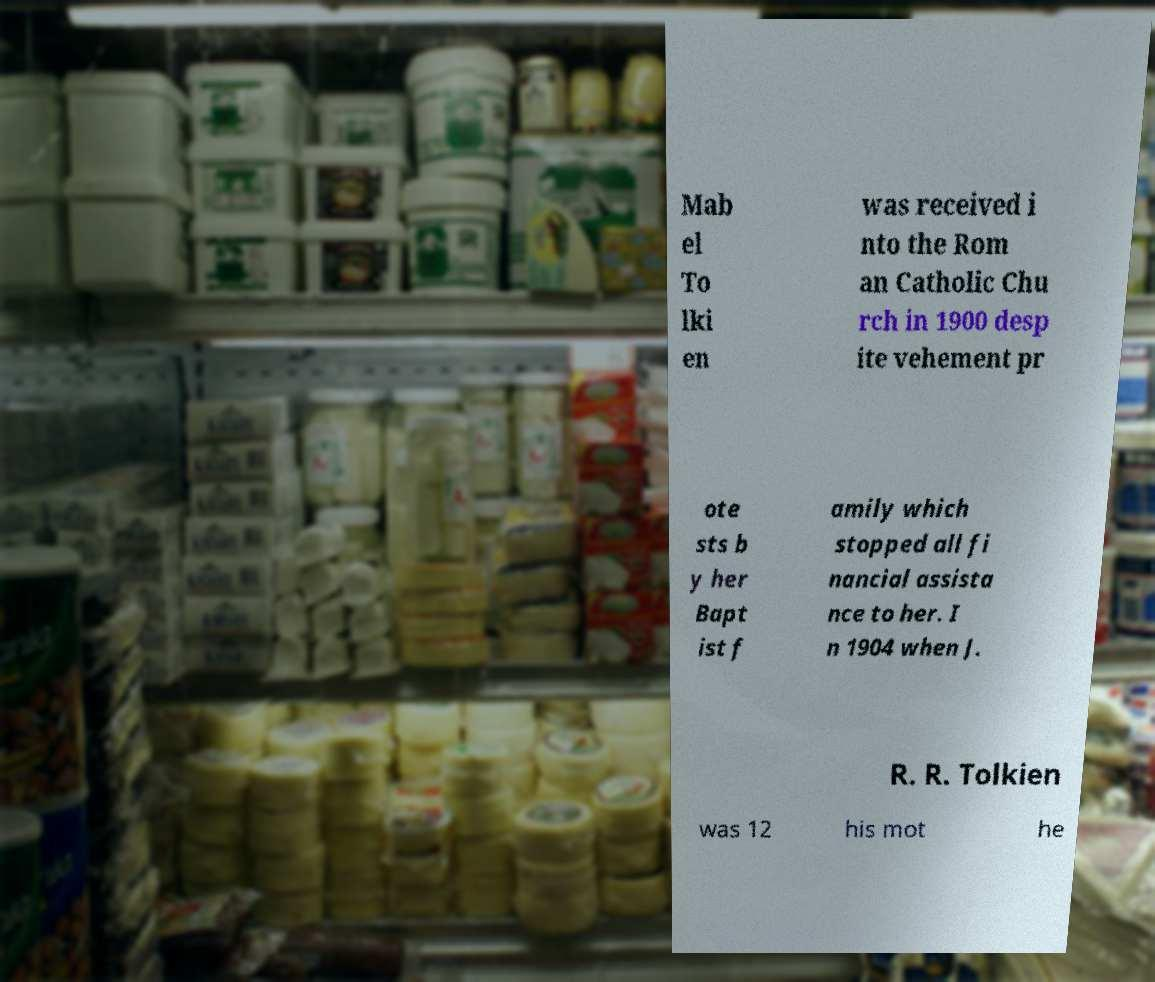For documentation purposes, I need the text within this image transcribed. Could you provide that? Mab el To lki en was received i nto the Rom an Catholic Chu rch in 1900 desp ite vehement pr ote sts b y her Bapt ist f amily which stopped all fi nancial assista nce to her. I n 1904 when J. R. R. Tolkien was 12 his mot he 